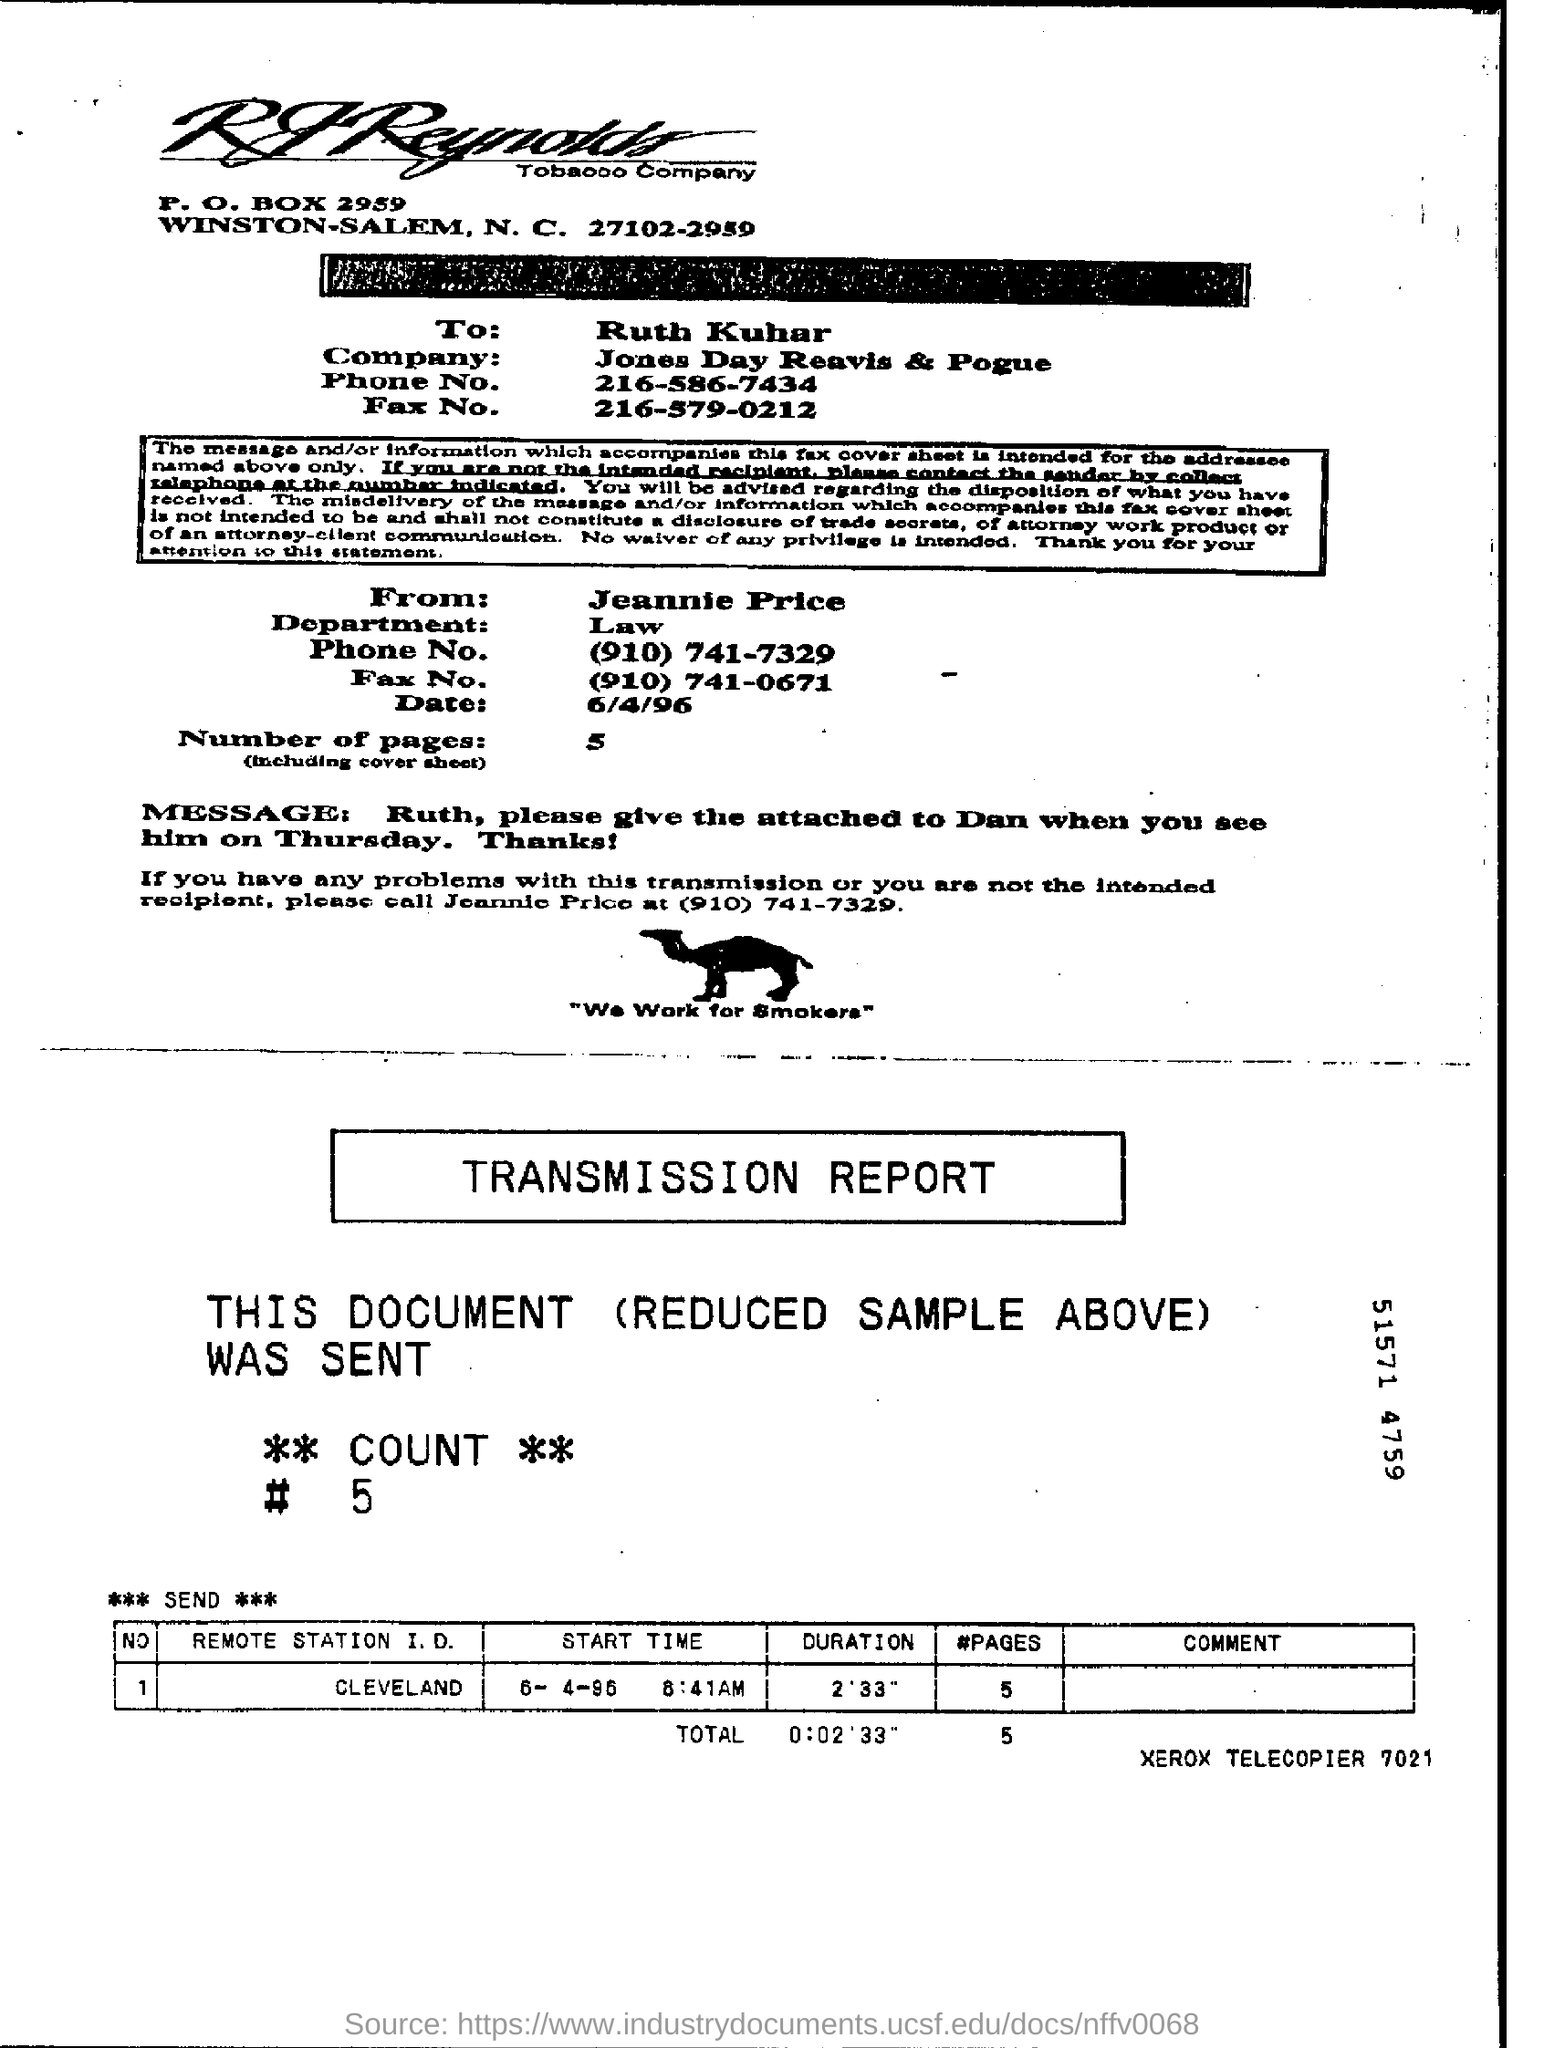Which department does Jeannie Price belong to?
Your response must be concise. Law. How many number of pages are mentioned?
Offer a terse response. 5. What is the remote station I.D
Give a very brief answer. CLEVELAND. 